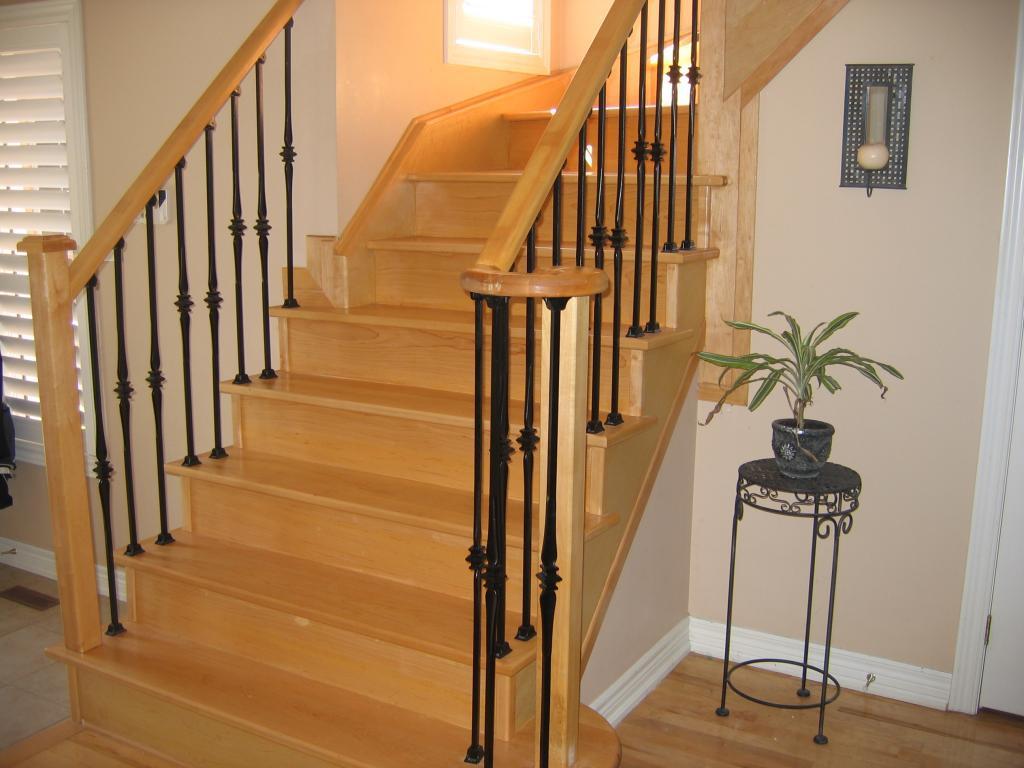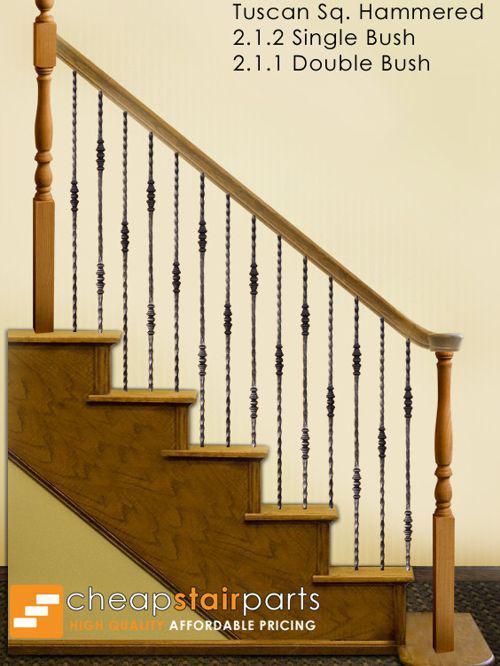The first image is the image on the left, the second image is the image on the right. Given the left and right images, does the statement "The staircase in the image on the right winds down in a circular fashion." hold true? Answer yes or no. No. The first image is the image on the left, the second image is the image on the right. Analyze the images presented: Is the assertion "The right image shows a curved staircase with a brown wood handrail and black wrought iron bars with a scroll embellishment." valid? Answer yes or no. No. 